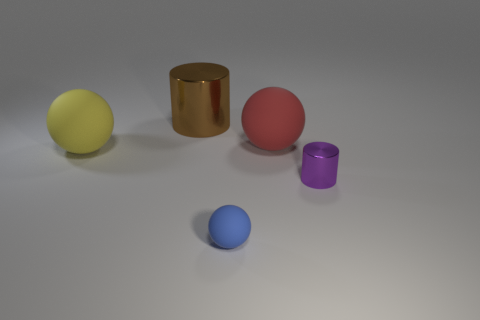Add 1 big yellow objects. How many objects exist? 6 Subtract all cylinders. How many objects are left? 3 Subtract all large matte things. Subtract all yellow rubber spheres. How many objects are left? 2 Add 4 small purple shiny things. How many small purple shiny things are left? 5 Add 3 gray metallic spheres. How many gray metallic spheres exist? 3 Subtract 0 green cylinders. How many objects are left? 5 